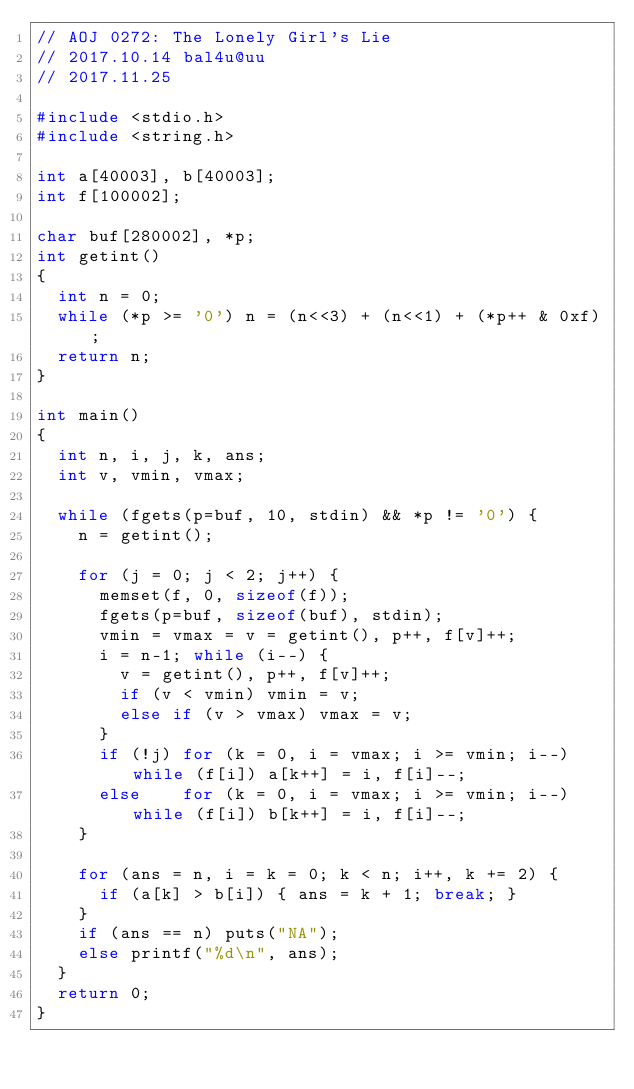<code> <loc_0><loc_0><loc_500><loc_500><_C_>// AOJ 0272: The Lonely Girl's Lie
// 2017.10.14 bal4u@uu
// 2017.11.25

#include <stdio.h>
#include <string.h>

int a[40003], b[40003];
int f[100002];

char buf[280002], *p;
int getint()
{
	int n = 0;
	while (*p >= '0') n = (n<<3) + (n<<1) + (*p++ & 0xf);
	return n;
}

int main()
{
	int n, i, j, k, ans;
	int v, vmin, vmax;

	while (fgets(p=buf, 10, stdin) && *p != '0') {
		n = getint();

		for (j = 0; j < 2; j++) {
			memset(f, 0, sizeof(f));
			fgets(p=buf, sizeof(buf), stdin);
			vmin = vmax = v = getint(), p++, f[v]++;
			i = n-1; while (i--) {
				v = getint(), p++, f[v]++;
				if (v < vmin) vmin = v;
				else if (v > vmax) vmax = v;
			}
			if (!j) for (k = 0, i = vmax; i >= vmin; i--) while (f[i]) a[k++] = i, f[i]--;
			else    for (k = 0, i = vmax; i >= vmin; i--) while (f[i]) b[k++] = i, f[i]--;
		}

		for (ans = n, i = k = 0; k < n; i++, k += 2) {
			if (a[k] > b[i]) { ans = k + 1; break; }
		}
		if (ans == n) puts("NA");
		else printf("%d\n", ans);
	}
	return 0;
}</code> 